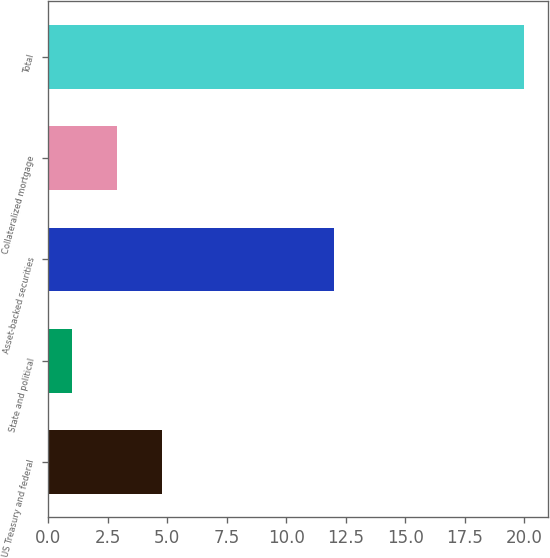Convert chart. <chart><loc_0><loc_0><loc_500><loc_500><bar_chart><fcel>US Treasury and federal<fcel>State and political<fcel>Asset-backed securities<fcel>Collateralized mortgage<fcel>Total<nl><fcel>4.8<fcel>1<fcel>12<fcel>2.9<fcel>20<nl></chart> 